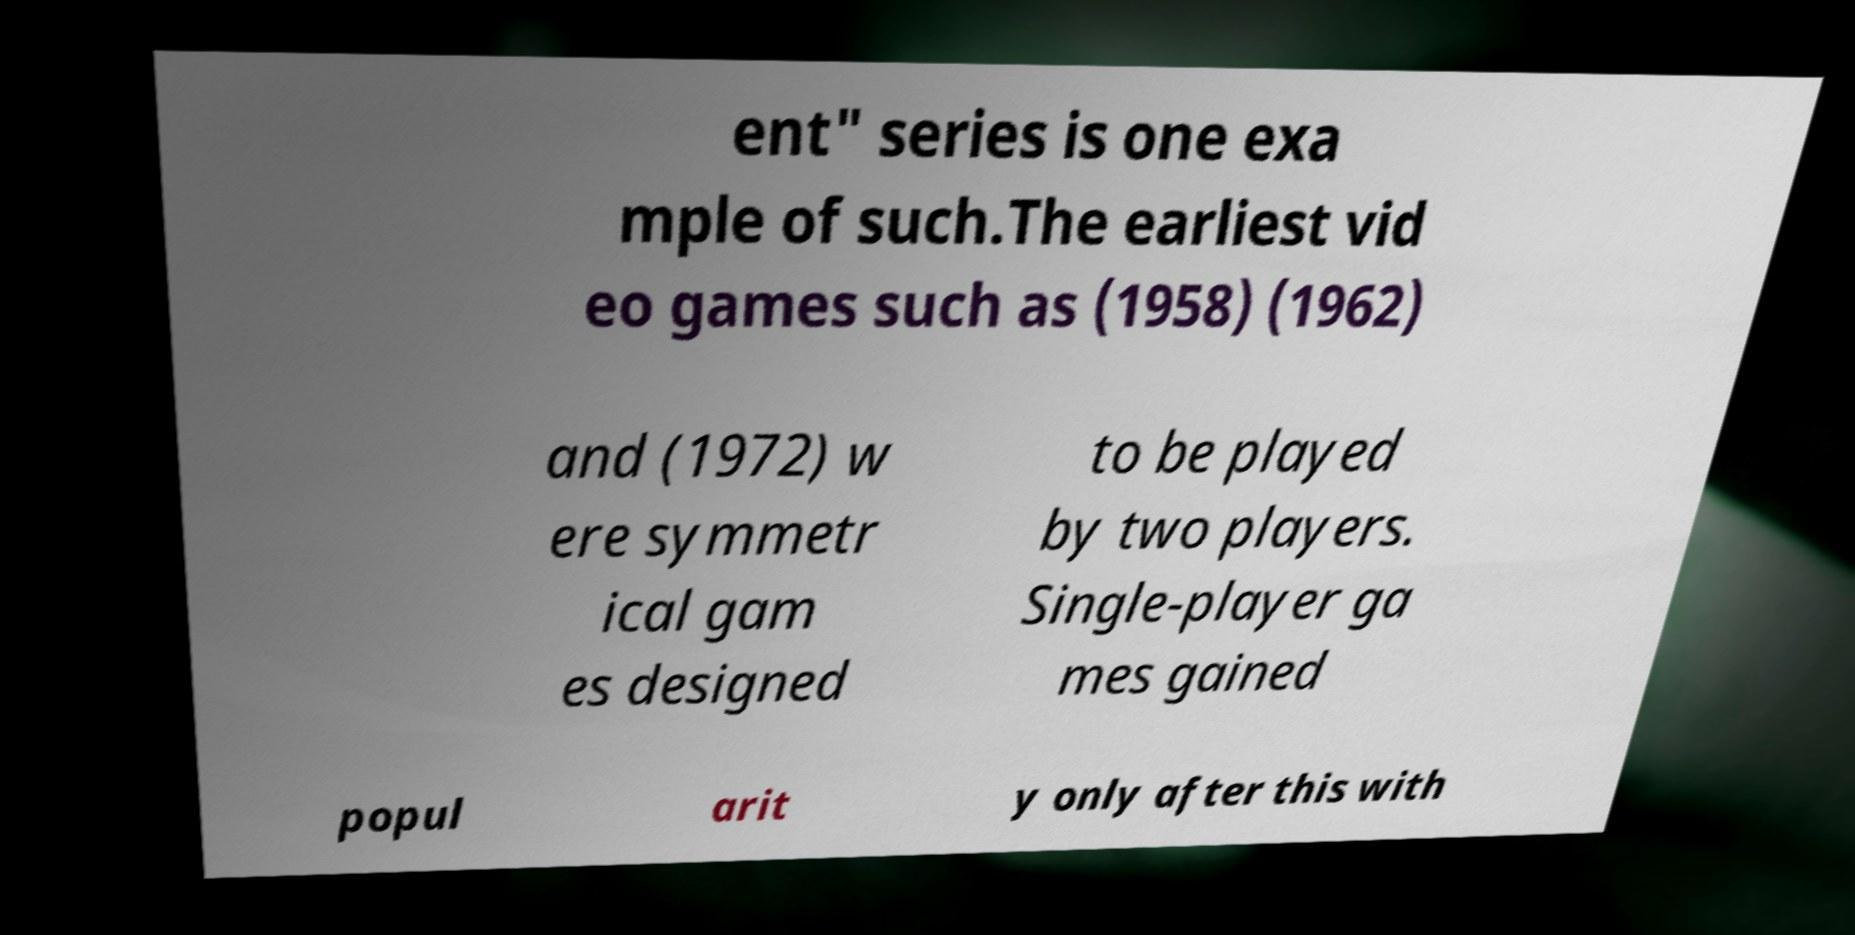There's text embedded in this image that I need extracted. Can you transcribe it verbatim? ent" series is one exa mple of such.The earliest vid eo games such as (1958) (1962) and (1972) w ere symmetr ical gam es designed to be played by two players. Single-player ga mes gained popul arit y only after this with 